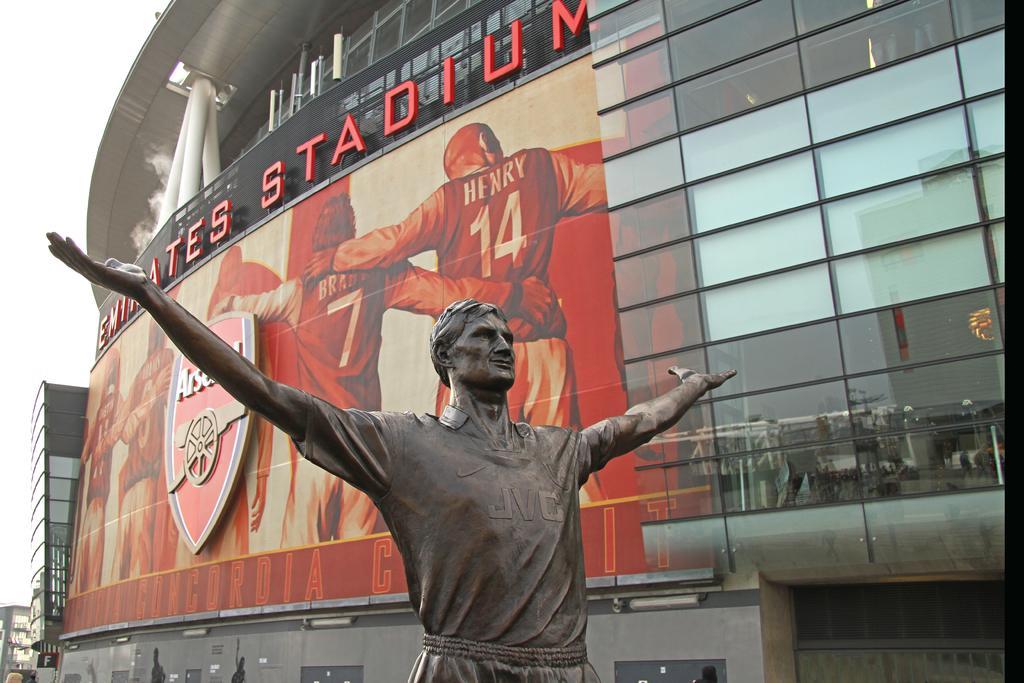Please provide a concise description of this image. In this image we can see a statue. On the backside we can see some buildings. We can also see a board with some pictures on it, a shield, pipes and some text on the mesh. We can also see the sky. 